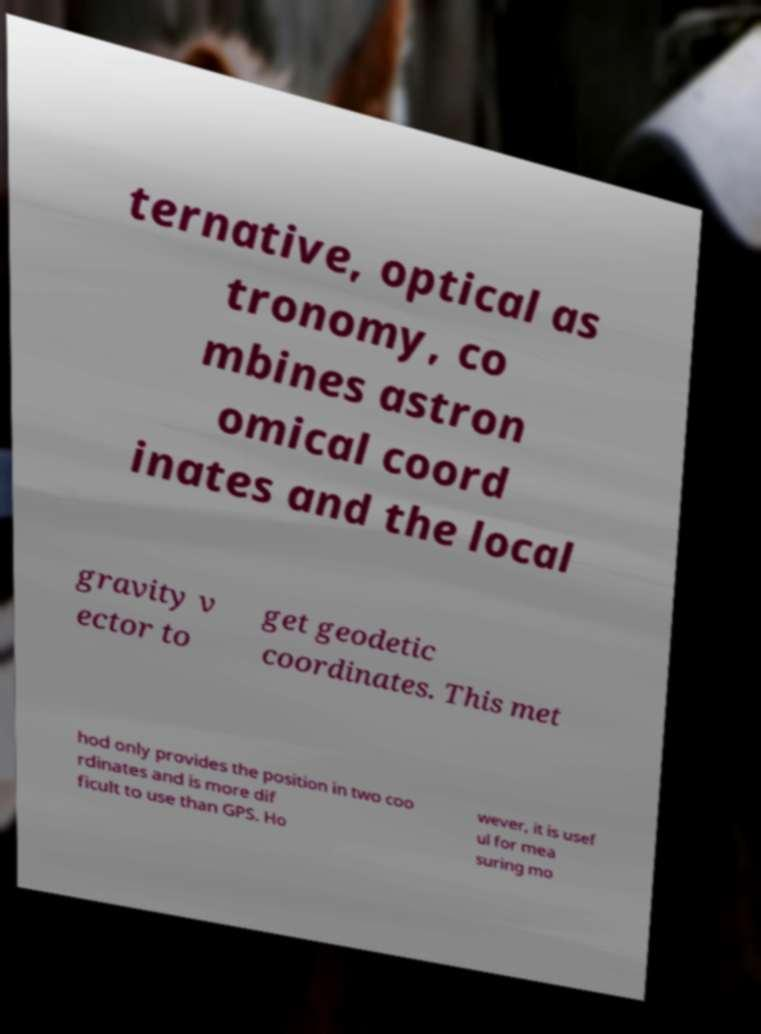Could you extract and type out the text from this image? ternative, optical as tronomy, co mbines astron omical coord inates and the local gravity v ector to get geodetic coordinates. This met hod only provides the position in two coo rdinates and is more dif ficult to use than GPS. Ho wever, it is usef ul for mea suring mo 